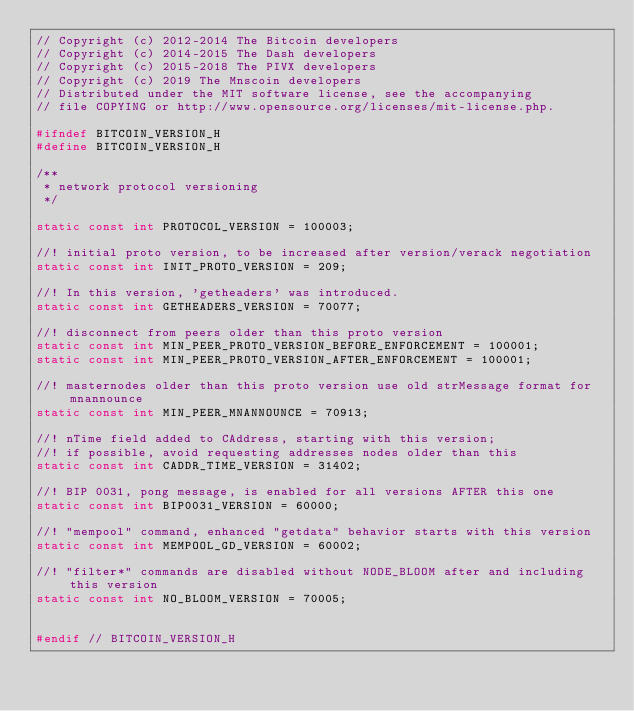<code> <loc_0><loc_0><loc_500><loc_500><_C_>// Copyright (c) 2012-2014 The Bitcoin developers
// Copyright (c) 2014-2015 The Dash developers
// Copyright (c) 2015-2018 The PIVX developers
// Copyright (c) 2019 The Mnscoin developers
// Distributed under the MIT software license, see the accompanying
// file COPYING or http://www.opensource.org/licenses/mit-license.php.

#ifndef BITCOIN_VERSION_H
#define BITCOIN_VERSION_H

/**
 * network protocol versioning
 */

static const int PROTOCOL_VERSION = 100003;

//! initial proto version, to be increased after version/verack negotiation
static const int INIT_PROTO_VERSION = 209;

//! In this version, 'getheaders' was introduced.
static const int GETHEADERS_VERSION = 70077;

//! disconnect from peers older than this proto version
static const int MIN_PEER_PROTO_VERSION_BEFORE_ENFORCEMENT = 100001;
static const int MIN_PEER_PROTO_VERSION_AFTER_ENFORCEMENT = 100001;

//! masternodes older than this proto version use old strMessage format for mnannounce
static const int MIN_PEER_MNANNOUNCE = 70913;

//! nTime field added to CAddress, starting with this version;
//! if possible, avoid requesting addresses nodes older than this
static const int CADDR_TIME_VERSION = 31402;

//! BIP 0031, pong message, is enabled for all versions AFTER this one
static const int BIP0031_VERSION = 60000;

//! "mempool" command, enhanced "getdata" behavior starts with this version
static const int MEMPOOL_GD_VERSION = 60002;

//! "filter*" commands are disabled without NODE_BLOOM after and including this version
static const int NO_BLOOM_VERSION = 70005;


#endif // BITCOIN_VERSION_H
</code> 